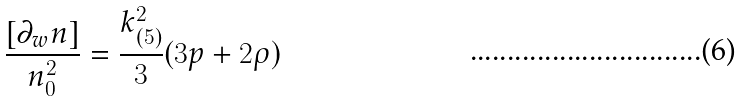<formula> <loc_0><loc_0><loc_500><loc_500>\frac { [ \partial _ { w } n ] } { n _ { 0 } ^ { 2 } } = \frac { k _ { ( 5 ) } ^ { 2 } } { 3 } ( 3 p + 2 \rho )</formula> 